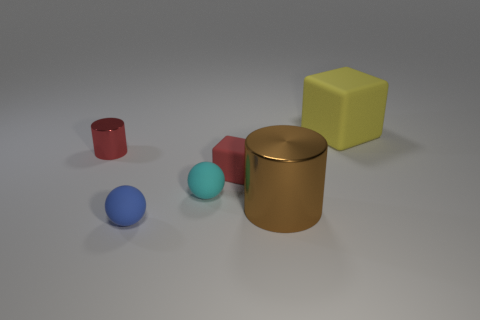The red rubber object that is the same shape as the large yellow rubber object is what size?
Your answer should be very brief. Small. What number of things are both in front of the small red metal cylinder and behind the small blue object?
Keep it short and to the point. 3. There is a blue object; is it the same shape as the red object that is on the right side of the blue thing?
Ensure brevity in your answer.  No. Are there more big things that are left of the big yellow matte object than large brown shiny blocks?
Your response must be concise. Yes. Is the number of small balls to the left of the small cyan sphere less than the number of small red metal cylinders?
Ensure brevity in your answer.  No. What number of small cubes are the same color as the tiny metal cylinder?
Provide a succinct answer. 1. The thing that is both to the right of the small red block and in front of the red metal object is made of what material?
Your answer should be very brief. Metal. Do the metallic thing left of the blue object and the cube that is left of the brown metal cylinder have the same color?
Offer a terse response. Yes. How many cyan things are either small rubber spheres or big metallic objects?
Your answer should be compact. 1. Are there fewer small spheres that are on the right side of the cyan sphere than tiny red rubber objects that are in front of the big rubber thing?
Ensure brevity in your answer.  Yes. 